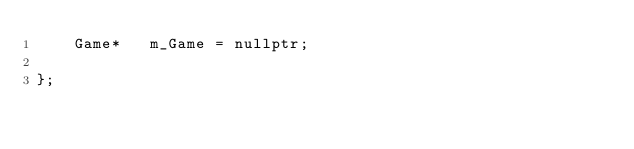<code> <loc_0><loc_0><loc_500><loc_500><_C_>    Game*   m_Game = nullptr;

};

</code> 